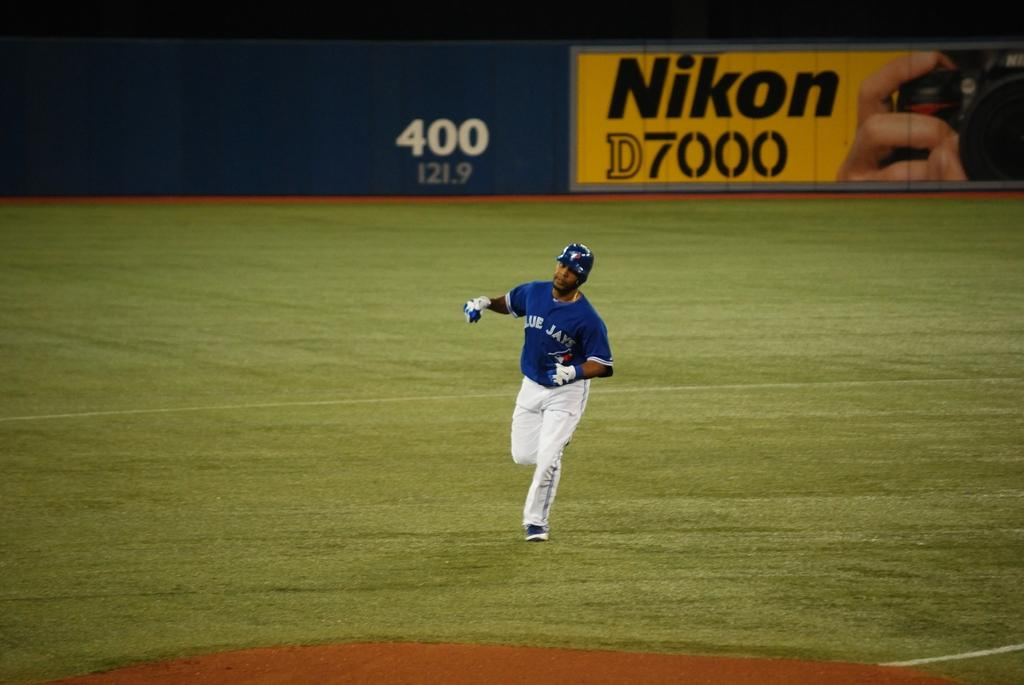<image>
Provide a brief description of the given image. A baseball player in a Blue Jays uniform running on a field with Nikon advertisement in the background. 